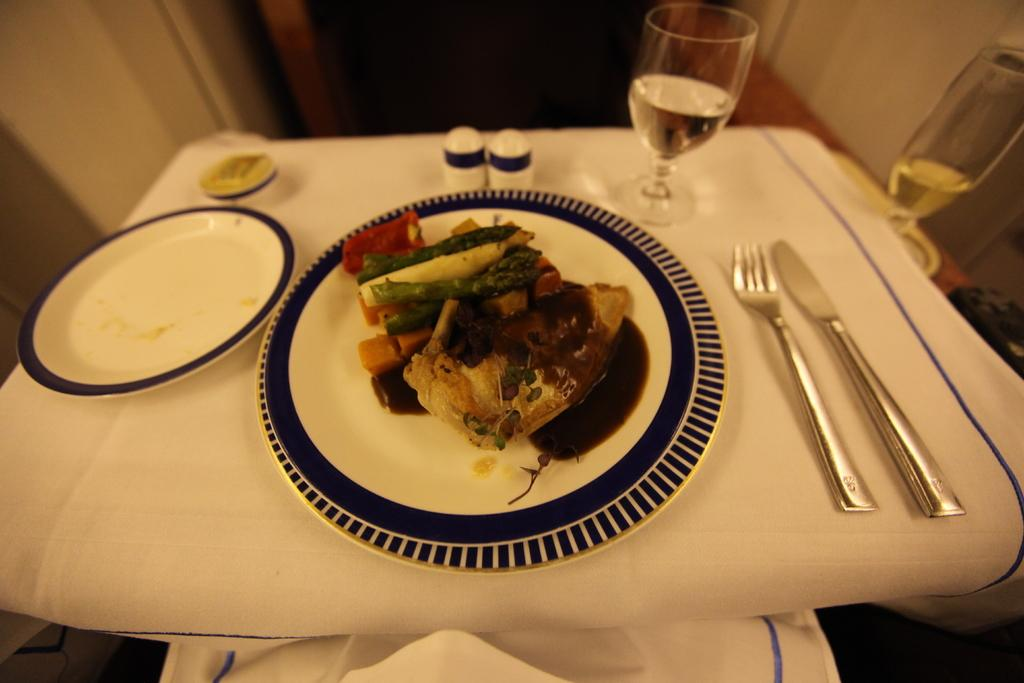What piece of furniture is present in the image? There is a table in the image. What is placed on the table? There are plates on the table. What is on the plates? There is food on the plates. What utensils can be seen in the image? There is a fork and a knife in the image. How many glasses are visible in the image? There are two glasses in the image. Can you describe any other items on the table? There are other unspecified items on the table. What type of friends are interacting with the mice in the image? There are no mice or friends present in the image. What is the purpose of the food on the plates in the image? The purpose of the food on the plates cannot be determined from the image alone, as it could be for eating, decoration, or any other reason. 